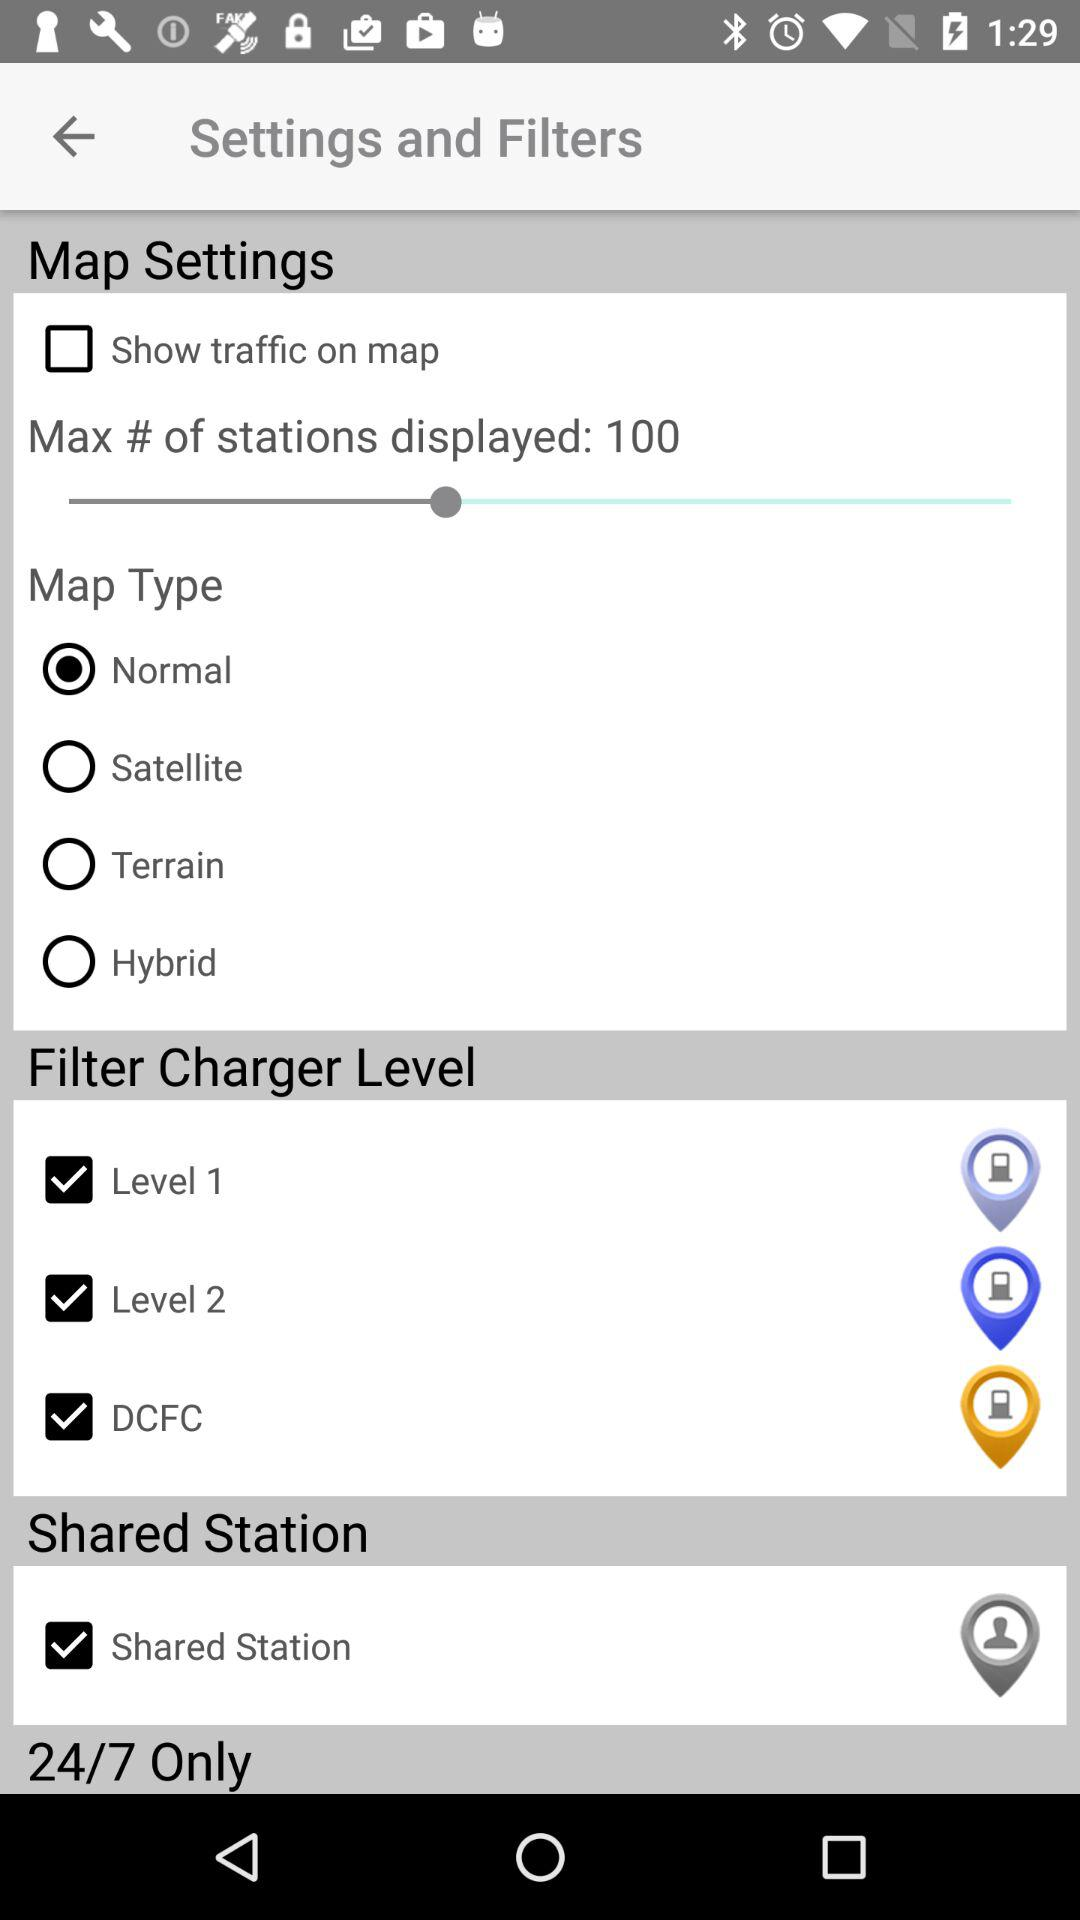What is the status of "Shared Station"? The status is "on". 